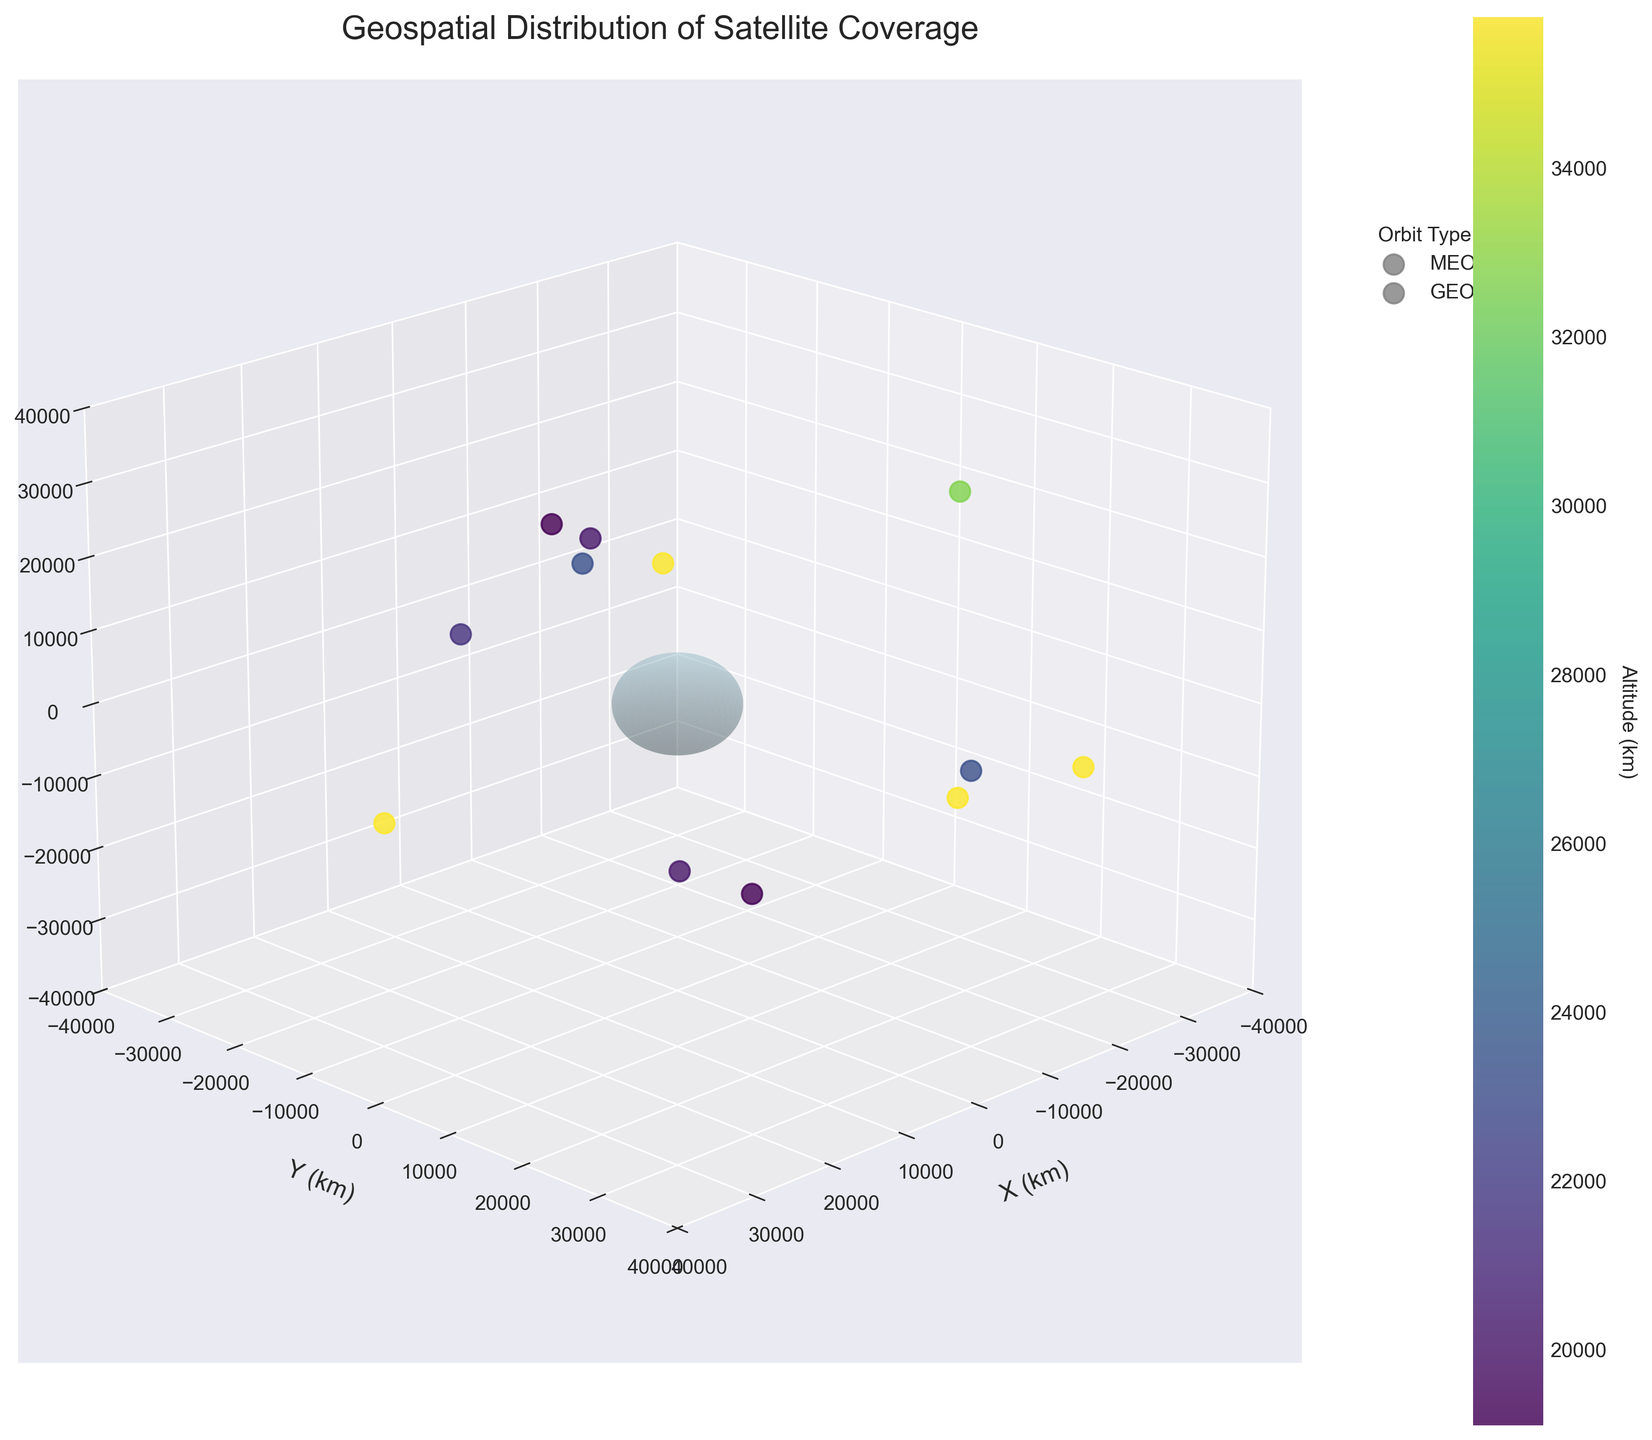What's the title of the figure? The title is located at the top of the figure and provides a summary of what the plot represents. It reads "Geospatial Distribution of Satellite Coverage."
Answer: Geospatial Distribution of Satellite Coverage How many satellites are shown in the plot? By counting the number of data points (satellites) in the scatter plot, we determine there are 12 data points representing satellites.
Answer: 12 Which orbit type appears most frequently in the plot? We need to identify the labels in the legend and count the satellites associated with each orbit type. "MEO" appears more frequently with more data points compared to "GEO".
Answer: MEO What is the altitude of the highest satellite? Observing the color bar on the right side of the plot, the highest altitude corresponds to the darkest color. The highest value is 35786 km, which matches multiple satellites.
Answer: 35786 km Compare the altitudes of "GPS IIF-1" and "BeiDou-3 G2". Which one is higher? Locate both satellites in the 3D plot by their positions or orbit types. "BeiDou-3 G2" has an altitude of 35786 km, while "GPS IIF-1" has an altitude of 20200 km. "BeiDou-3 G2" is higher.
Answer: BeiDou-3 G2 Which satellite has the lowest latitude? Compare the latitudes of all satellites by looking at their positions along the Z-axis. "GLONASS-M" has the lowest latitude of -42.3 degrees.
Answer: GLONASS-M How many satellites are located at the equator (latitude = 0)? By examining the scatter plot along the equator (zero latitude line), we see that there are 3 data points: "BeiDou-3 G2", "SBAS WAAS", and "SBAS EGNOS".
Answer: 3 What's the average altitude of all MEO satellites? Identify all MEO satellites and sum their altitudes: (20200 + 19100 + 23222 + 21528 + 20180 + 19140 + 23222). Divide by the number of MEO satellites (7). Average altitude: (157592/7)
Answer: 22513 km Are there any satellites in the southern hemisphere (latitude < 0)? Check the positions of the satellites with latitudes less than 0. "GPS IIF-1", "Galileo FOC-M8", and "GLONASS-M" are in the southern hemisphere.
Answer: Yes Which satellite is positioned furthest east? Compare the longitudes to find the highest positive value. "Galileo FOC-M8" has the highest longitude at 122.3 degrees.
Answer: Galileo FOC-M8 